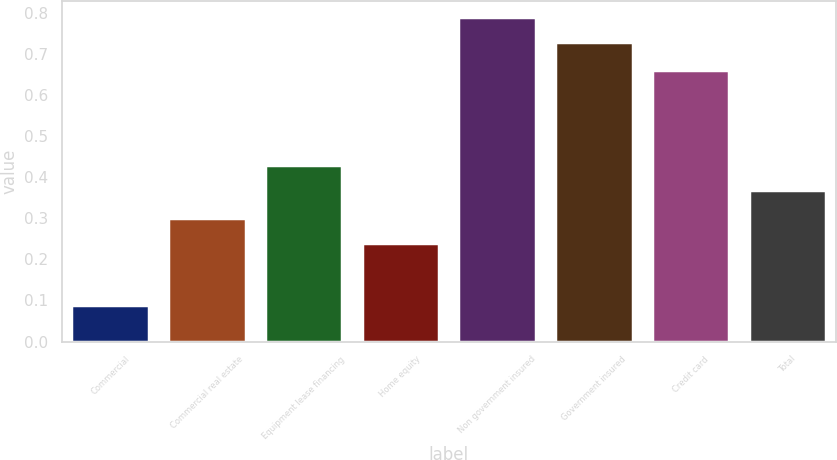<chart> <loc_0><loc_0><loc_500><loc_500><bar_chart><fcel>Commercial<fcel>Commercial real estate<fcel>Equipment lease financing<fcel>Home equity<fcel>Non government insured<fcel>Government insured<fcel>Credit card<fcel>Total<nl><fcel>0.09<fcel>0.3<fcel>0.43<fcel>0.24<fcel>0.79<fcel>0.73<fcel>0.66<fcel>0.37<nl></chart> 